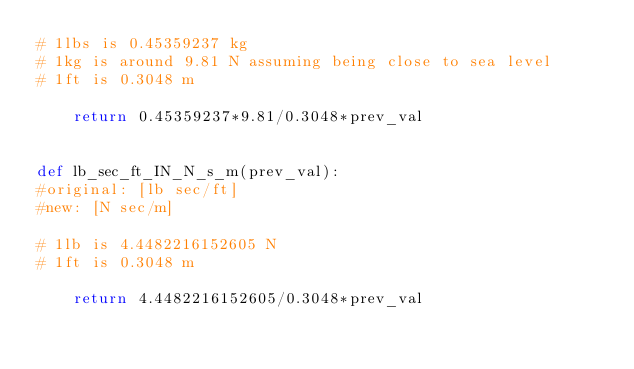<code> <loc_0><loc_0><loc_500><loc_500><_Python_># 1lbs is 0.45359237 kg
# 1kg is around 9.81 N assuming being close to sea level
# 1ft is 0.3048 m

    return 0.45359237*9.81/0.3048*prev_val 


def lb_sec_ft_IN_N_s_m(prev_val):
#original: [lb sec/ft]
#new: [N sec/m]

# 1lb is 4.4482216152605 N
# 1ft is 0.3048 m

    return 4.4482216152605/0.3048*prev_val 

</code> 